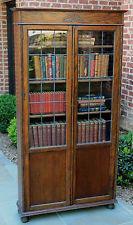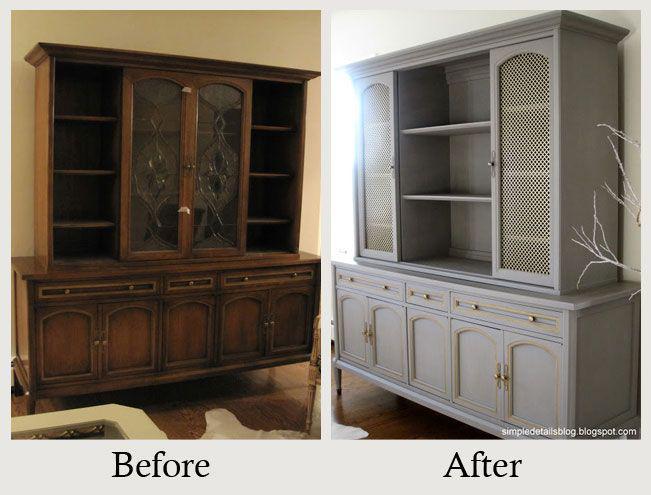The first image is the image on the left, the second image is the image on the right. Given the left and right images, does the statement "A bookcase in one image has upper glass doors with panes, over a solid lower section." hold true? Answer yes or no. Yes. 